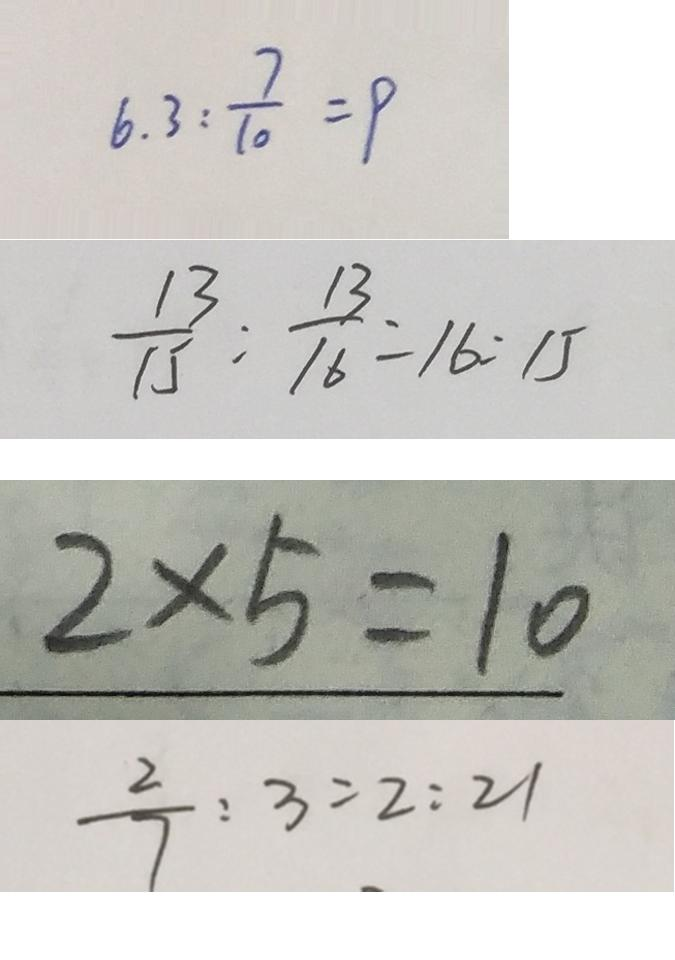<formula> <loc_0><loc_0><loc_500><loc_500>6 . 3 : \frac { 7 } { 1 0 } = 9 
 \frac { 1 3 } { 1 5 } : \frac { 1 3 } { 1 6 } = 1 6 : 1 5 
 2 \times 5 = 1 0 
 \frac { 2 } { 7 } : 3 = 2 : 2 1</formula> 